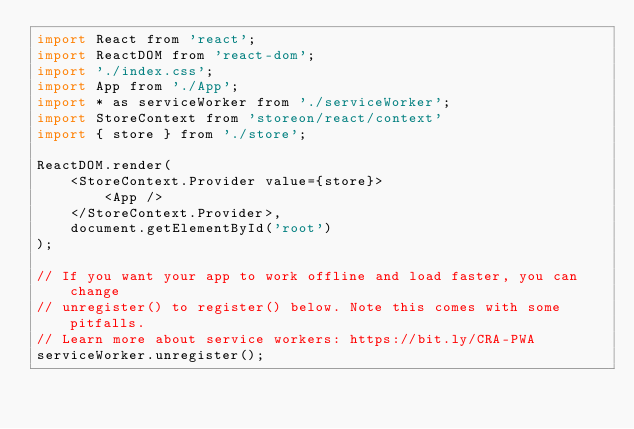Convert code to text. <code><loc_0><loc_0><loc_500><loc_500><_JavaScript_>import React from 'react';
import ReactDOM from 'react-dom';
import './index.css';
import App from './App';
import * as serviceWorker from './serviceWorker';
import StoreContext from 'storeon/react/context'
import { store } from './store';

ReactDOM.render(
    <StoreContext.Provider value={store}>
        <App />
    </StoreContext.Provider>,
    document.getElementById('root')
);

// If you want your app to work offline and load faster, you can change
// unregister() to register() below. Note this comes with some pitfalls.
// Learn more about service workers: https://bit.ly/CRA-PWA
serviceWorker.unregister();
</code> 